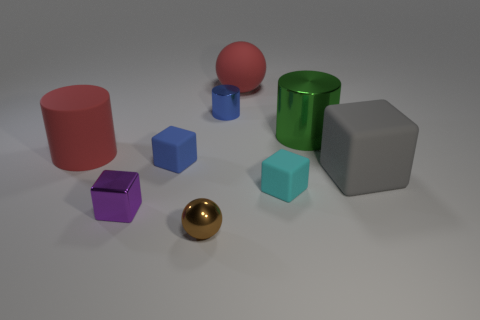Does the big matte cylinder have the same color as the large ball?
Offer a very short reply. Yes. The cyan rubber object that is the same shape as the tiny blue matte thing is what size?
Your answer should be compact. Small. What number of cylinders are the same material as the small brown sphere?
Your answer should be compact. 2. Is the material of the small blue cylinder behind the large red cylinder the same as the large red ball?
Offer a very short reply. No. Are there the same number of small cubes that are on the left side of the tiny shiny cylinder and small purple metallic things?
Your answer should be compact. No. The blue cylinder is what size?
Provide a short and direct response. Small. What material is the cylinder that is the same color as the rubber ball?
Offer a very short reply. Rubber. What number of big objects are the same color as the large rubber ball?
Offer a very short reply. 1. Is the size of the blue shiny cylinder the same as the red matte ball?
Offer a very short reply. No. There is a blue object in front of the big green metallic cylinder behind the large gray matte block; what size is it?
Your answer should be compact. Small. 